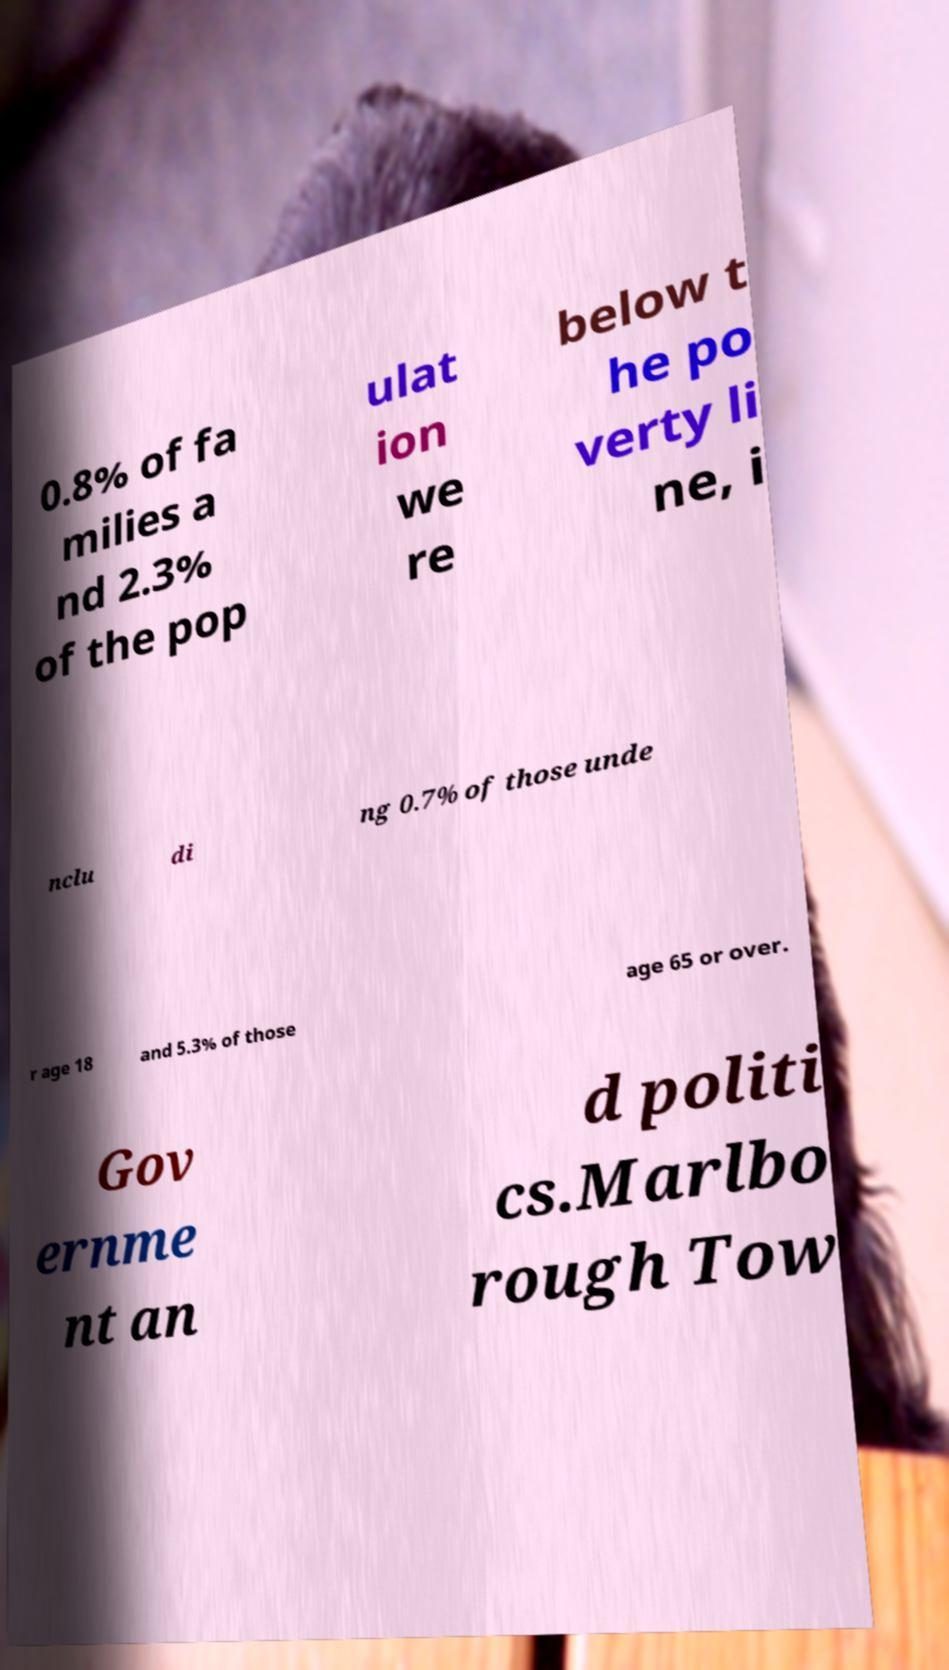For documentation purposes, I need the text within this image transcribed. Could you provide that? 0.8% of fa milies a nd 2.3% of the pop ulat ion we re below t he po verty li ne, i nclu di ng 0.7% of those unde r age 18 and 5.3% of those age 65 or over. Gov ernme nt an d politi cs.Marlbo rough Tow 